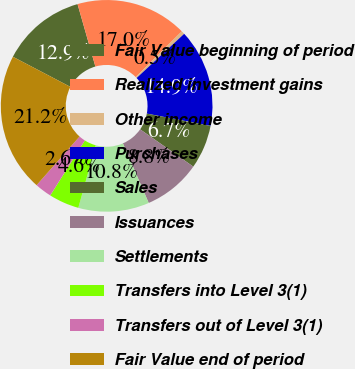Convert chart. <chart><loc_0><loc_0><loc_500><loc_500><pie_chart><fcel>Fair Value beginning of period<fcel>Realized investment gains<fcel>Other income<fcel>Purchases<fcel>Sales<fcel>Issuances<fcel>Settlements<fcel>Transfers into Level 3(1)<fcel>Transfers out of Level 3(1)<fcel>Fair Value end of period<nl><fcel>12.89%<fcel>17.01%<fcel>0.51%<fcel>14.95%<fcel>6.7%<fcel>8.76%<fcel>10.82%<fcel>4.63%<fcel>2.57%<fcel>21.16%<nl></chart> 